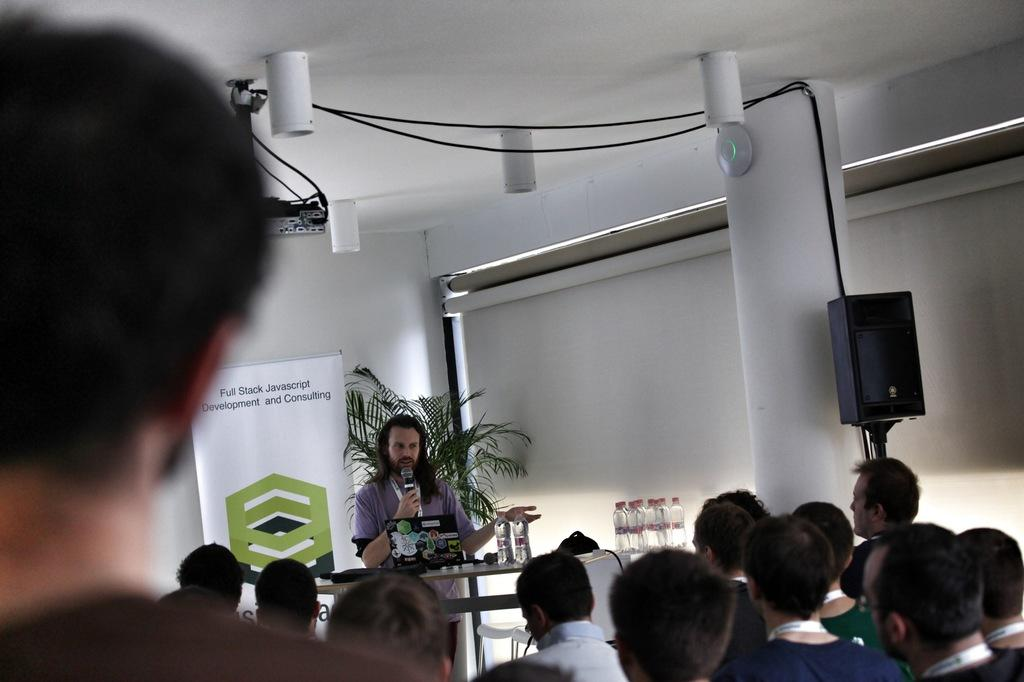What are the people in the image doing? The people in the image are sitting. What is the person in front of the desk doing? The person is standing in front of a desk. What can be seen on the desk? The desk has bottles on it. What is visible behind the desk? There is a poster behind the desk. What year is depicted on the tub in the image? There is no tub present in the image, so the year cannot be determined. 